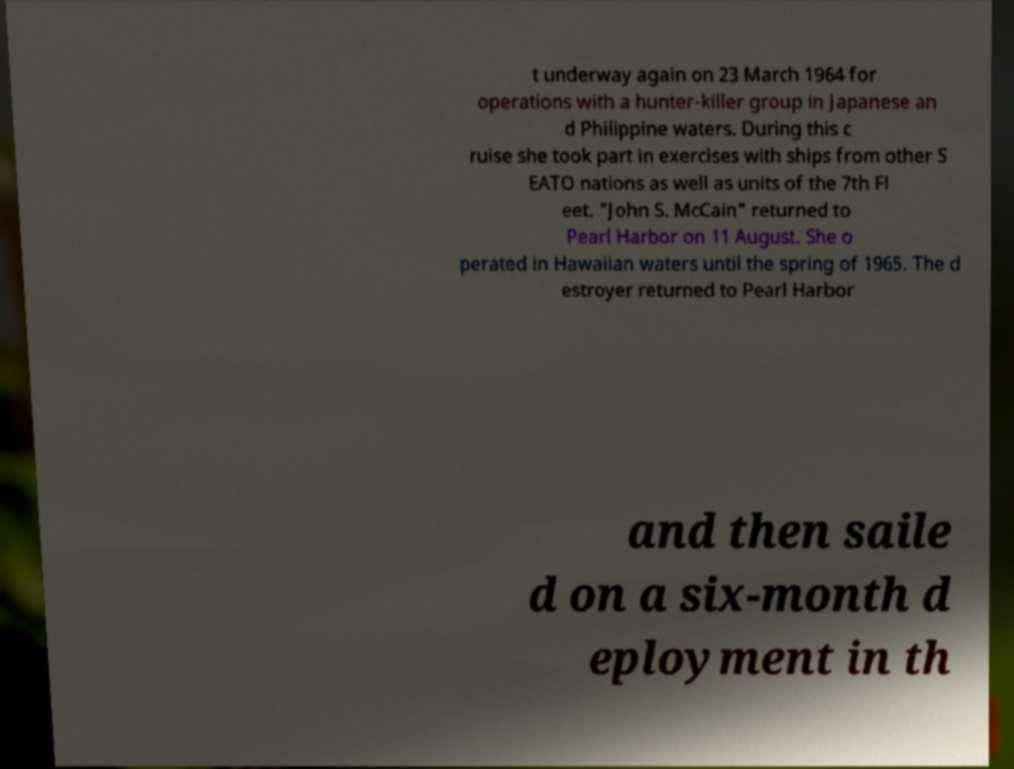Please identify and transcribe the text found in this image. t underway again on 23 March 1964 for operations with a hunter-killer group in Japanese an d Philippine waters. During this c ruise she took part in exercises with ships from other S EATO nations as well as units of the 7th Fl eet. "John S. McCain" returned to Pearl Harbor on 11 August. She o perated in Hawaiian waters until the spring of 1965. The d estroyer returned to Pearl Harbor and then saile d on a six-month d eployment in th 